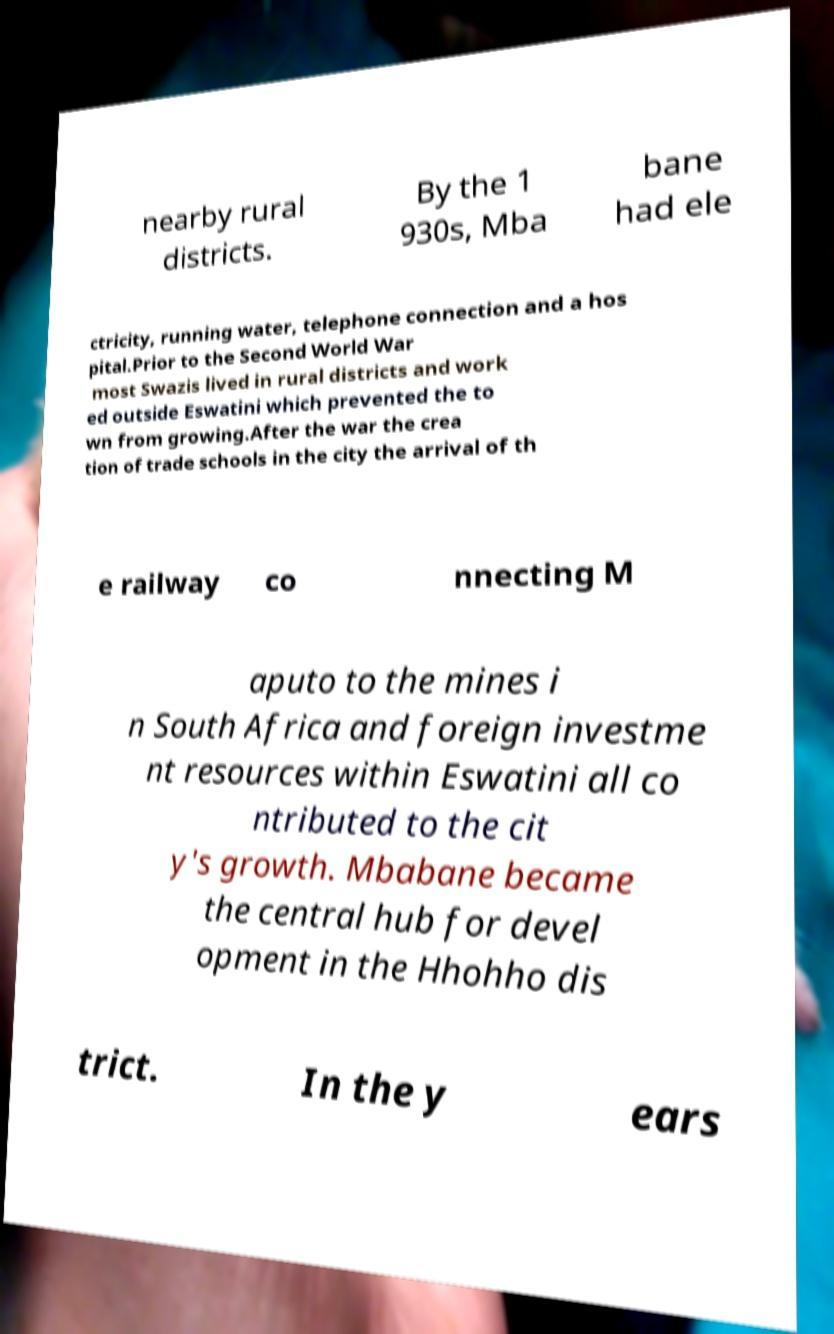Can you read and provide the text displayed in the image?This photo seems to have some interesting text. Can you extract and type it out for me? nearby rural districts. By the 1 930s, Mba bane had ele ctricity, running water, telephone connection and a hos pital.Prior to the Second World War most Swazis lived in rural districts and work ed outside Eswatini which prevented the to wn from growing.After the war the crea tion of trade schools in the city the arrival of th e railway co nnecting M aputo to the mines i n South Africa and foreign investme nt resources within Eswatini all co ntributed to the cit y's growth. Mbabane became the central hub for devel opment in the Hhohho dis trict. In the y ears 